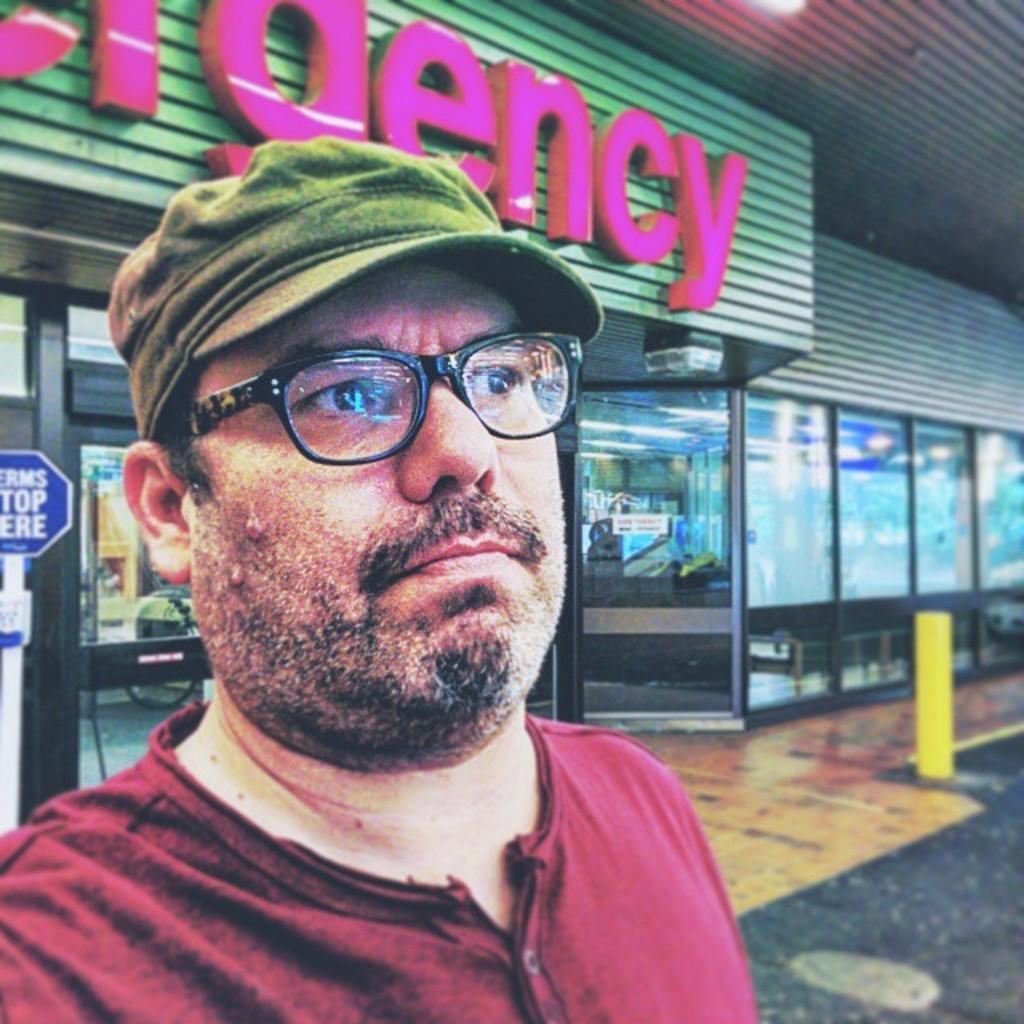Could you give a brief overview of what you see in this image? In this image I can see a man in the front. I can see he is wearing maroon colour t shirt, a specs and a cap. Behind him I can see a building, number of boards, doors and on these words I can see something is written. 